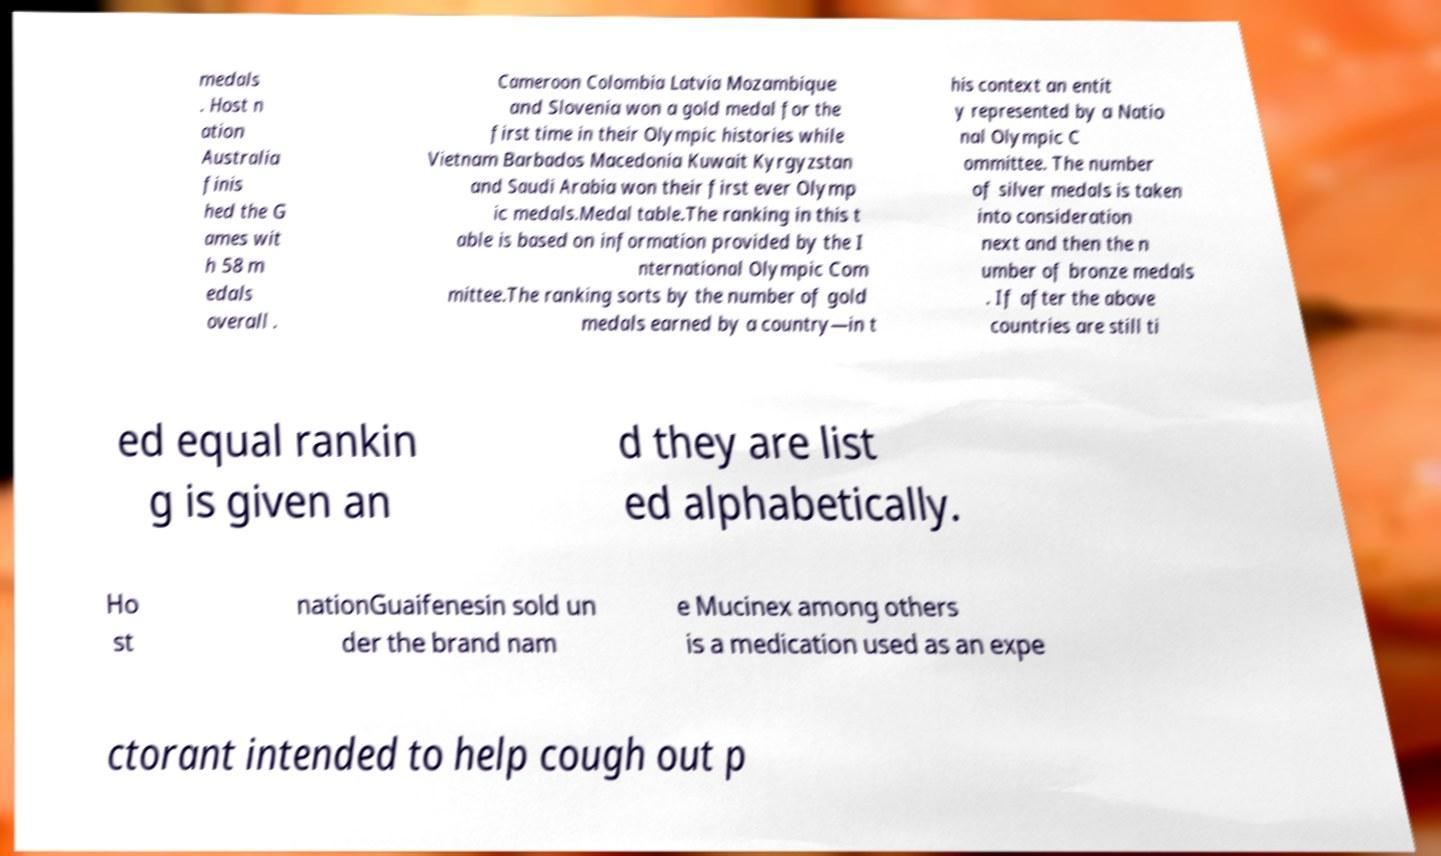For documentation purposes, I need the text within this image transcribed. Could you provide that? medals . Host n ation Australia finis hed the G ames wit h 58 m edals overall . Cameroon Colombia Latvia Mozambique and Slovenia won a gold medal for the first time in their Olympic histories while Vietnam Barbados Macedonia Kuwait Kyrgyzstan and Saudi Arabia won their first ever Olymp ic medals.Medal table.The ranking in this t able is based on information provided by the I nternational Olympic Com mittee.The ranking sorts by the number of gold medals earned by a country—in t his context an entit y represented by a Natio nal Olympic C ommittee. The number of silver medals is taken into consideration next and then the n umber of bronze medals . If after the above countries are still ti ed equal rankin g is given an d they are list ed alphabetically. Ho st nationGuaifenesin sold un der the brand nam e Mucinex among others is a medication used as an expe ctorant intended to help cough out p 